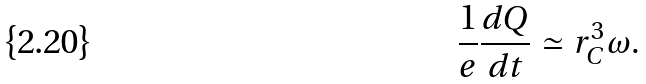<formula> <loc_0><loc_0><loc_500><loc_500>\frac { 1 } { e } \frac { d Q } { d t } \simeq r _ { C } ^ { 3 } \omega .</formula> 